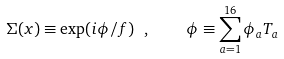Convert formula to latex. <formula><loc_0><loc_0><loc_500><loc_500>\Sigma ( x ) \equiv \exp ( i \phi / f ) \ , \quad \phi \equiv \sum _ { a = 1 } ^ { 1 6 } \phi _ { a } T _ { a } \,</formula> 